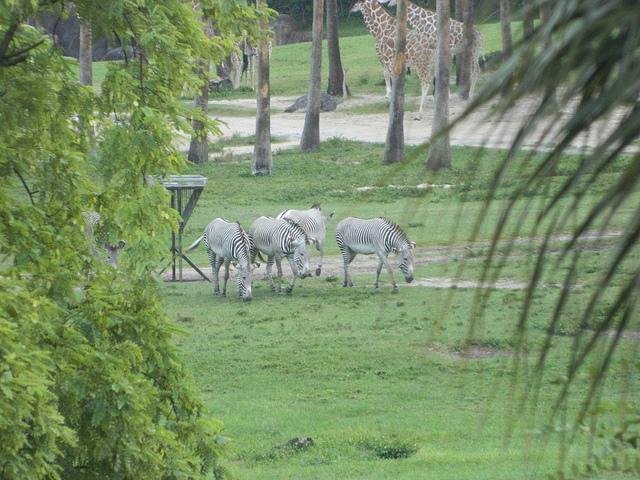Where are these Zebras most likely living together with the giraffes? zoo 